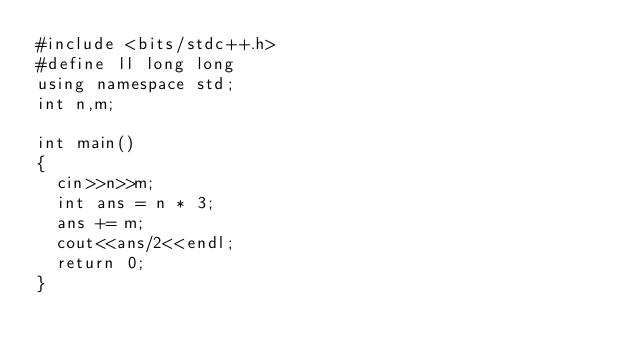Convert code to text. <code><loc_0><loc_0><loc_500><loc_500><_C++_>#include <bits/stdc++.h>
#define ll long long
using namespace std;
int n,m;

int main()
{
  cin>>n>>m;
  int ans = n * 3;
  ans += m;
  cout<<ans/2<<endl;
  return 0;
}</code> 